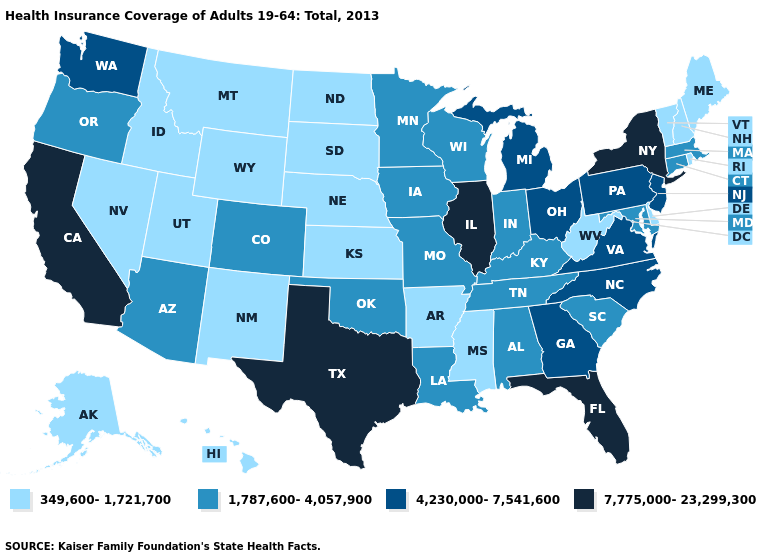What is the value of Delaware?
Write a very short answer. 349,600-1,721,700. What is the highest value in states that border New Jersey?
Give a very brief answer. 7,775,000-23,299,300. What is the lowest value in the Northeast?
Keep it brief. 349,600-1,721,700. Does New Jersey have the highest value in the Northeast?
Write a very short answer. No. Which states have the lowest value in the USA?
Short answer required. Alaska, Arkansas, Delaware, Hawaii, Idaho, Kansas, Maine, Mississippi, Montana, Nebraska, Nevada, New Hampshire, New Mexico, North Dakota, Rhode Island, South Dakota, Utah, Vermont, West Virginia, Wyoming. What is the value of Delaware?
Answer briefly. 349,600-1,721,700. What is the value of Indiana?
Answer briefly. 1,787,600-4,057,900. What is the value of Montana?
Keep it brief. 349,600-1,721,700. Name the states that have a value in the range 7,775,000-23,299,300?
Concise answer only. California, Florida, Illinois, New York, Texas. Which states have the lowest value in the USA?
Write a very short answer. Alaska, Arkansas, Delaware, Hawaii, Idaho, Kansas, Maine, Mississippi, Montana, Nebraska, Nevada, New Hampshire, New Mexico, North Dakota, Rhode Island, South Dakota, Utah, Vermont, West Virginia, Wyoming. What is the value of Rhode Island?
Concise answer only. 349,600-1,721,700. Does the map have missing data?
Give a very brief answer. No. Name the states that have a value in the range 349,600-1,721,700?
Short answer required. Alaska, Arkansas, Delaware, Hawaii, Idaho, Kansas, Maine, Mississippi, Montana, Nebraska, Nevada, New Hampshire, New Mexico, North Dakota, Rhode Island, South Dakota, Utah, Vermont, West Virginia, Wyoming. Name the states that have a value in the range 1,787,600-4,057,900?
Keep it brief. Alabama, Arizona, Colorado, Connecticut, Indiana, Iowa, Kentucky, Louisiana, Maryland, Massachusetts, Minnesota, Missouri, Oklahoma, Oregon, South Carolina, Tennessee, Wisconsin. 